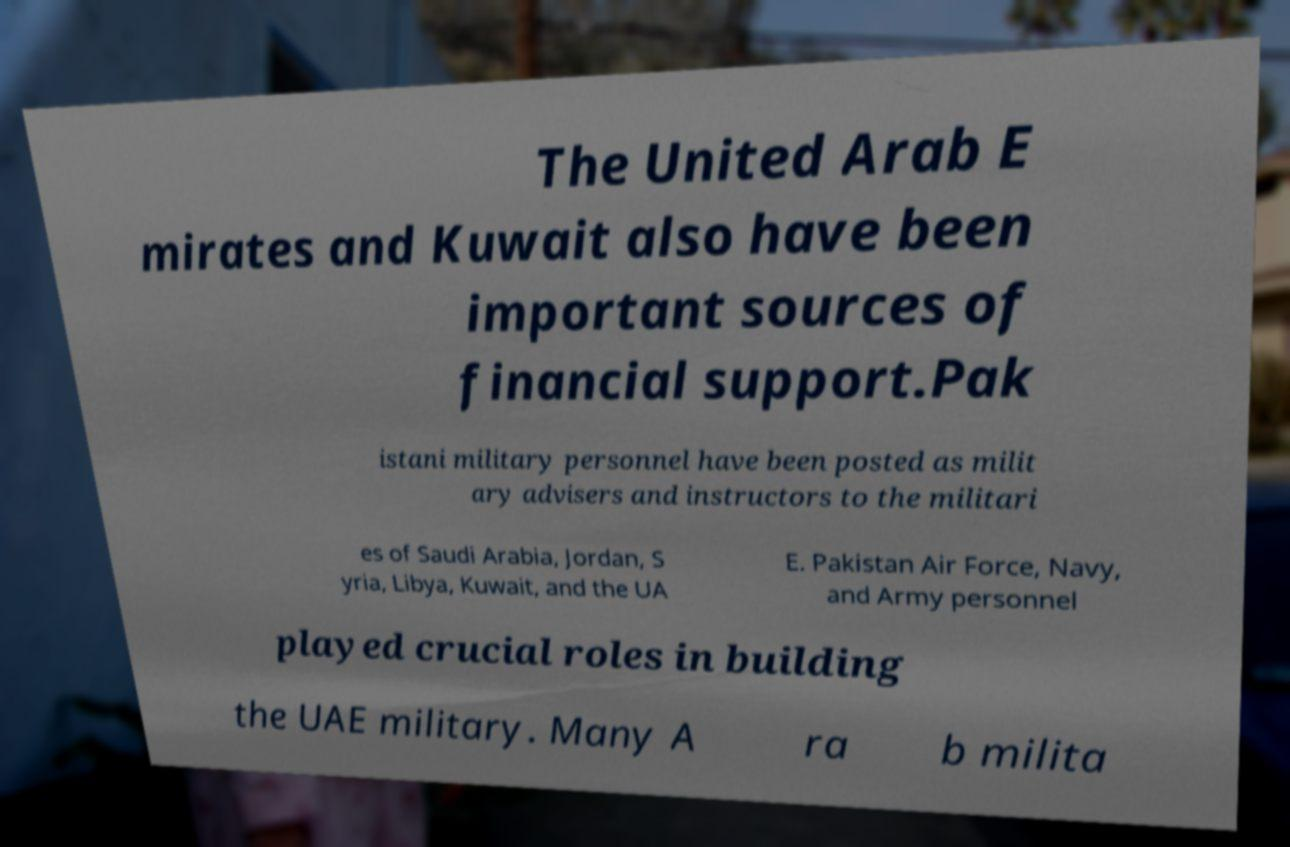Please identify and transcribe the text found in this image. The United Arab E mirates and Kuwait also have been important sources of financial support.Pak istani military personnel have been posted as milit ary advisers and instructors to the militari es of Saudi Arabia, Jordan, S yria, Libya, Kuwait, and the UA E. Pakistan Air Force, Navy, and Army personnel played crucial roles in building the UAE military. Many A ra b milita 